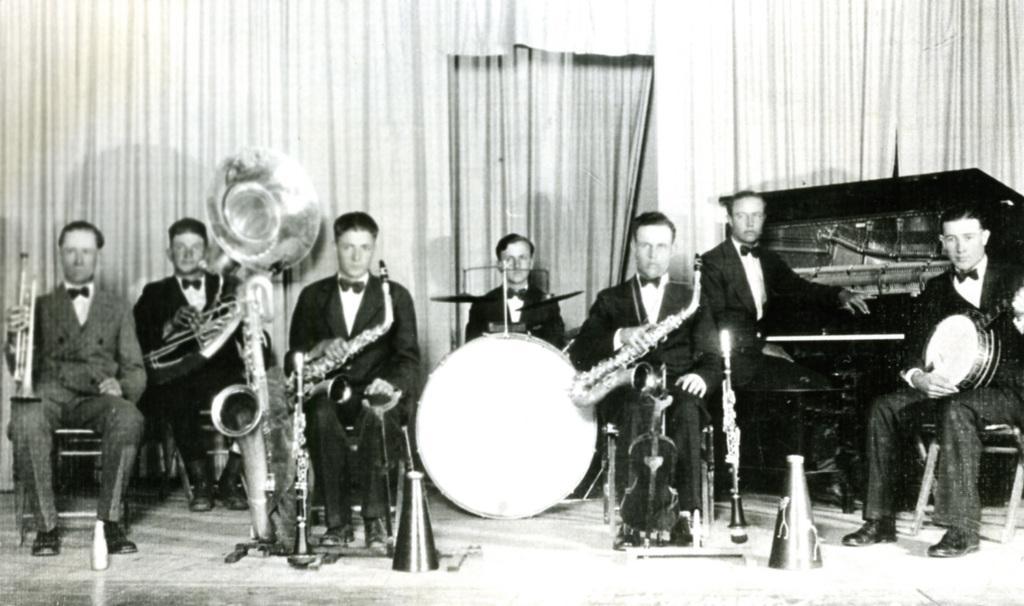In one or two sentences, can you explain what this image depicts? In the above picture i could see the persons holding musical instruments like trumpet, drums and then the right corner of the picture i could see a person sitting on the chair using a piano. In the background i could see the curtains hanging over. All men are dressed with blazers and bow tie tied to neck. 